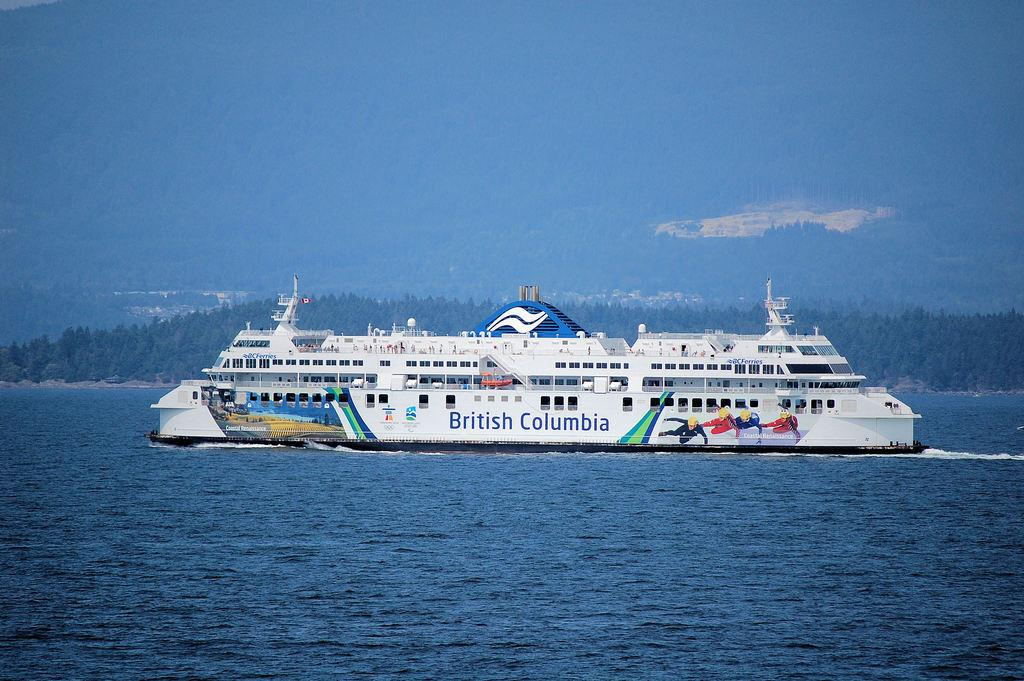<image>
Describe the image concisely. A British Columbia cruise ship is in the water. 